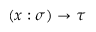<formula> <loc_0><loc_0><loc_500><loc_500>( x \colon \sigma ) \to \tau</formula> 